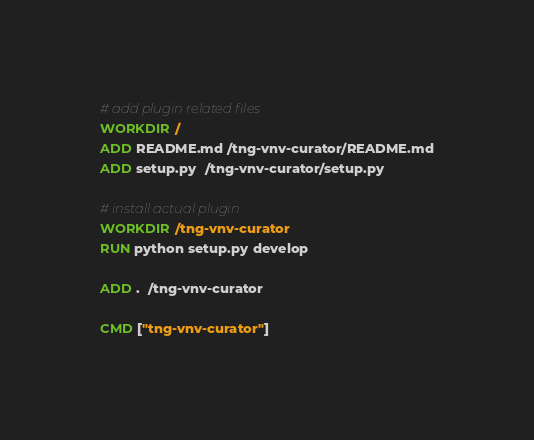<code> <loc_0><loc_0><loc_500><loc_500><_Dockerfile_># add plugin related files
WORKDIR /
ADD README.md /tng-vnv-curator/README.md
ADD setup.py  /tng-vnv-curator/setup.py

# install actual plugin
WORKDIR /tng-vnv-curator
RUN python setup.py develop

ADD .  /tng-vnv-curator

CMD ["tng-vnv-curator"]
</code> 